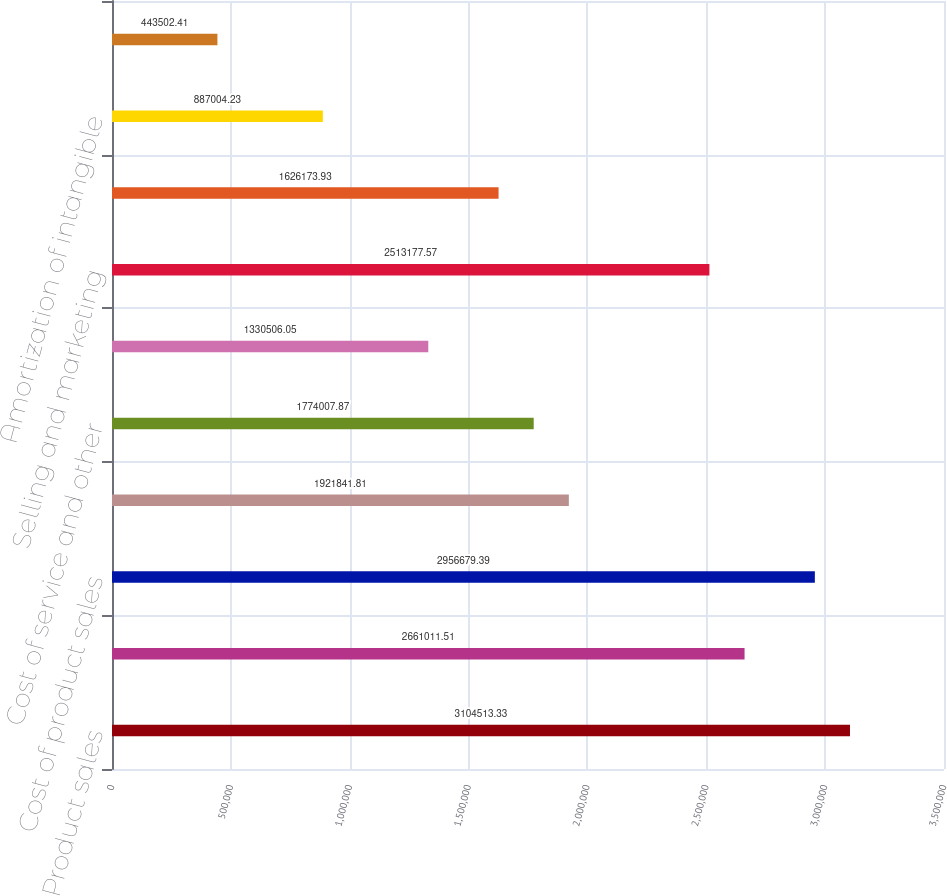Convert chart. <chart><loc_0><loc_0><loc_500><loc_500><bar_chart><fcel>Product sales<fcel>Service and other revenues<fcel>Cost of product sales<fcel>Cost of product<fcel>Cost of service and other<fcel>Research and development<fcel>Selling and marketing<fcel>General and administrative<fcel>Amortization of intangible<fcel>Litigation settlement charges<nl><fcel>3.10451e+06<fcel>2.66101e+06<fcel>2.95668e+06<fcel>1.92184e+06<fcel>1.77401e+06<fcel>1.33051e+06<fcel>2.51318e+06<fcel>1.62617e+06<fcel>887004<fcel>443502<nl></chart> 